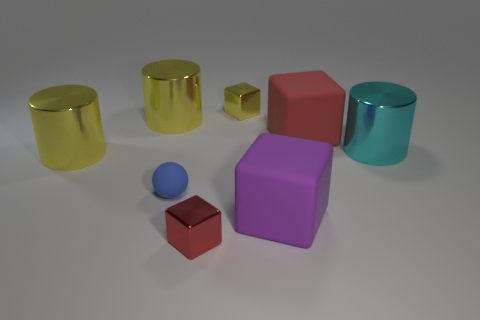What number of other things are there of the same material as the tiny blue object
Your answer should be very brief. 2. What material is the large cube that is on the left side of the red object on the right side of the shiny block that is in front of the cyan cylinder made of?
Your answer should be very brief. Rubber. Is the big cyan cylinder made of the same material as the tiny blue object?
Offer a terse response. No. How many cylinders are big metal objects or yellow objects?
Provide a succinct answer. 3. The tiny block behind the small red metallic cube is what color?
Give a very brief answer. Yellow. How many rubber objects are either large cyan objects or big red cylinders?
Give a very brief answer. 0. What material is the red thing to the right of the small shiny cube that is in front of the large cyan cylinder?
Your answer should be compact. Rubber. The small matte ball is what color?
Your answer should be very brief. Blue. There is a large metallic cylinder to the right of the purple rubber cube; is there a large yellow shiny cylinder that is in front of it?
Your answer should be very brief. Yes. What is the material of the large cyan cylinder?
Make the answer very short. Metal. 